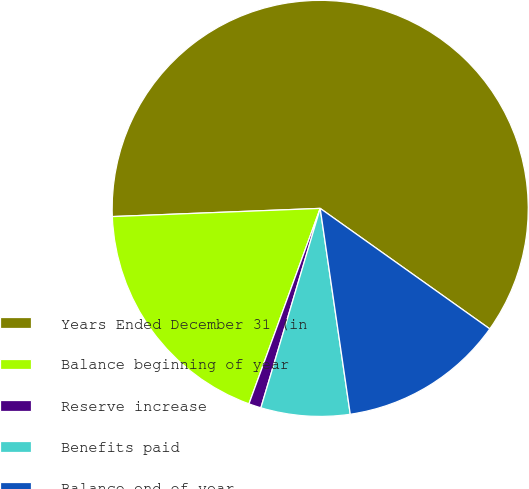Convert chart to OTSL. <chart><loc_0><loc_0><loc_500><loc_500><pie_chart><fcel>Years Ended December 31 (in<fcel>Balance beginning of year<fcel>Reserve increase<fcel>Benefits paid<fcel>Balance end of year<nl><fcel>60.46%<fcel>18.81%<fcel>0.96%<fcel>6.91%<fcel>12.86%<nl></chart> 